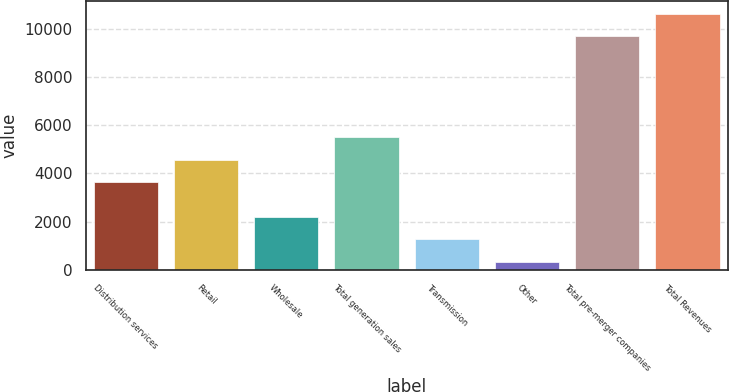<chart> <loc_0><loc_0><loc_500><loc_500><bar_chart><fcel>Distribution services<fcel>Retail<fcel>Wholesale<fcel>Total generation sales<fcel>Transmission<fcel>Other<fcel>Total pre-merger companies<fcel>Total Revenues<nl><fcel>3629<fcel>4567.4<fcel>2202.8<fcel>5505.8<fcel>1264.4<fcel>326<fcel>9710<fcel>10648.4<nl></chart> 